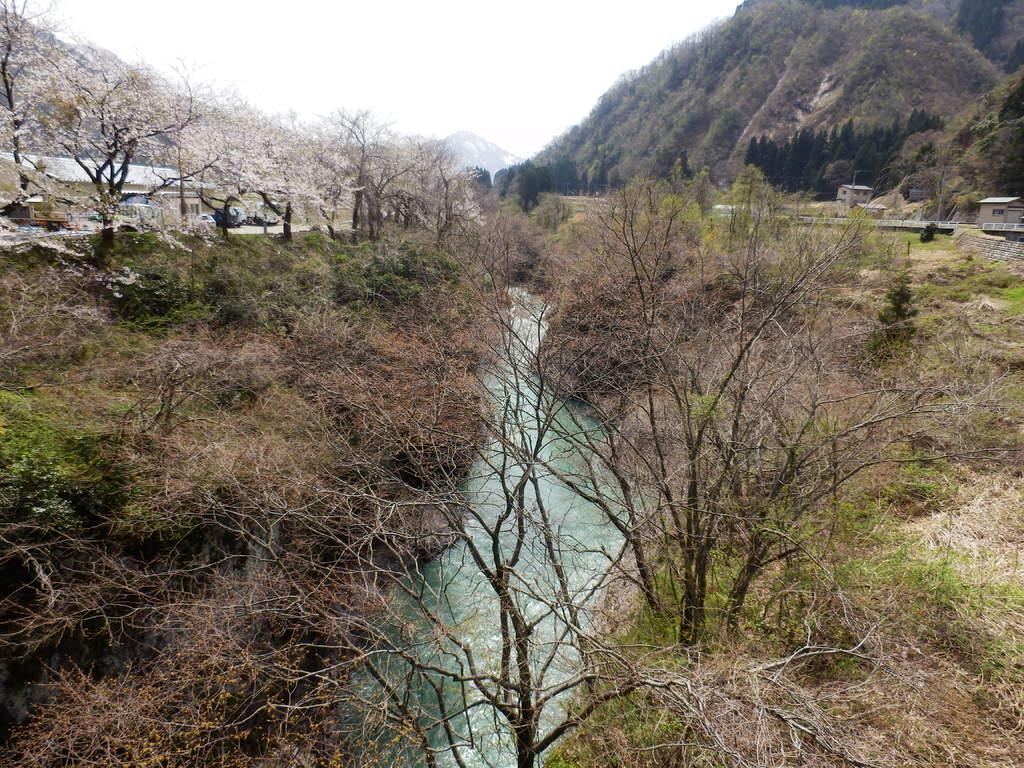Describe this image in one or two sentences. There are some trees at the bottom of this image and there is a house on the left side of this image and there are some mountains in the background. There is a sky at the top of this image. 